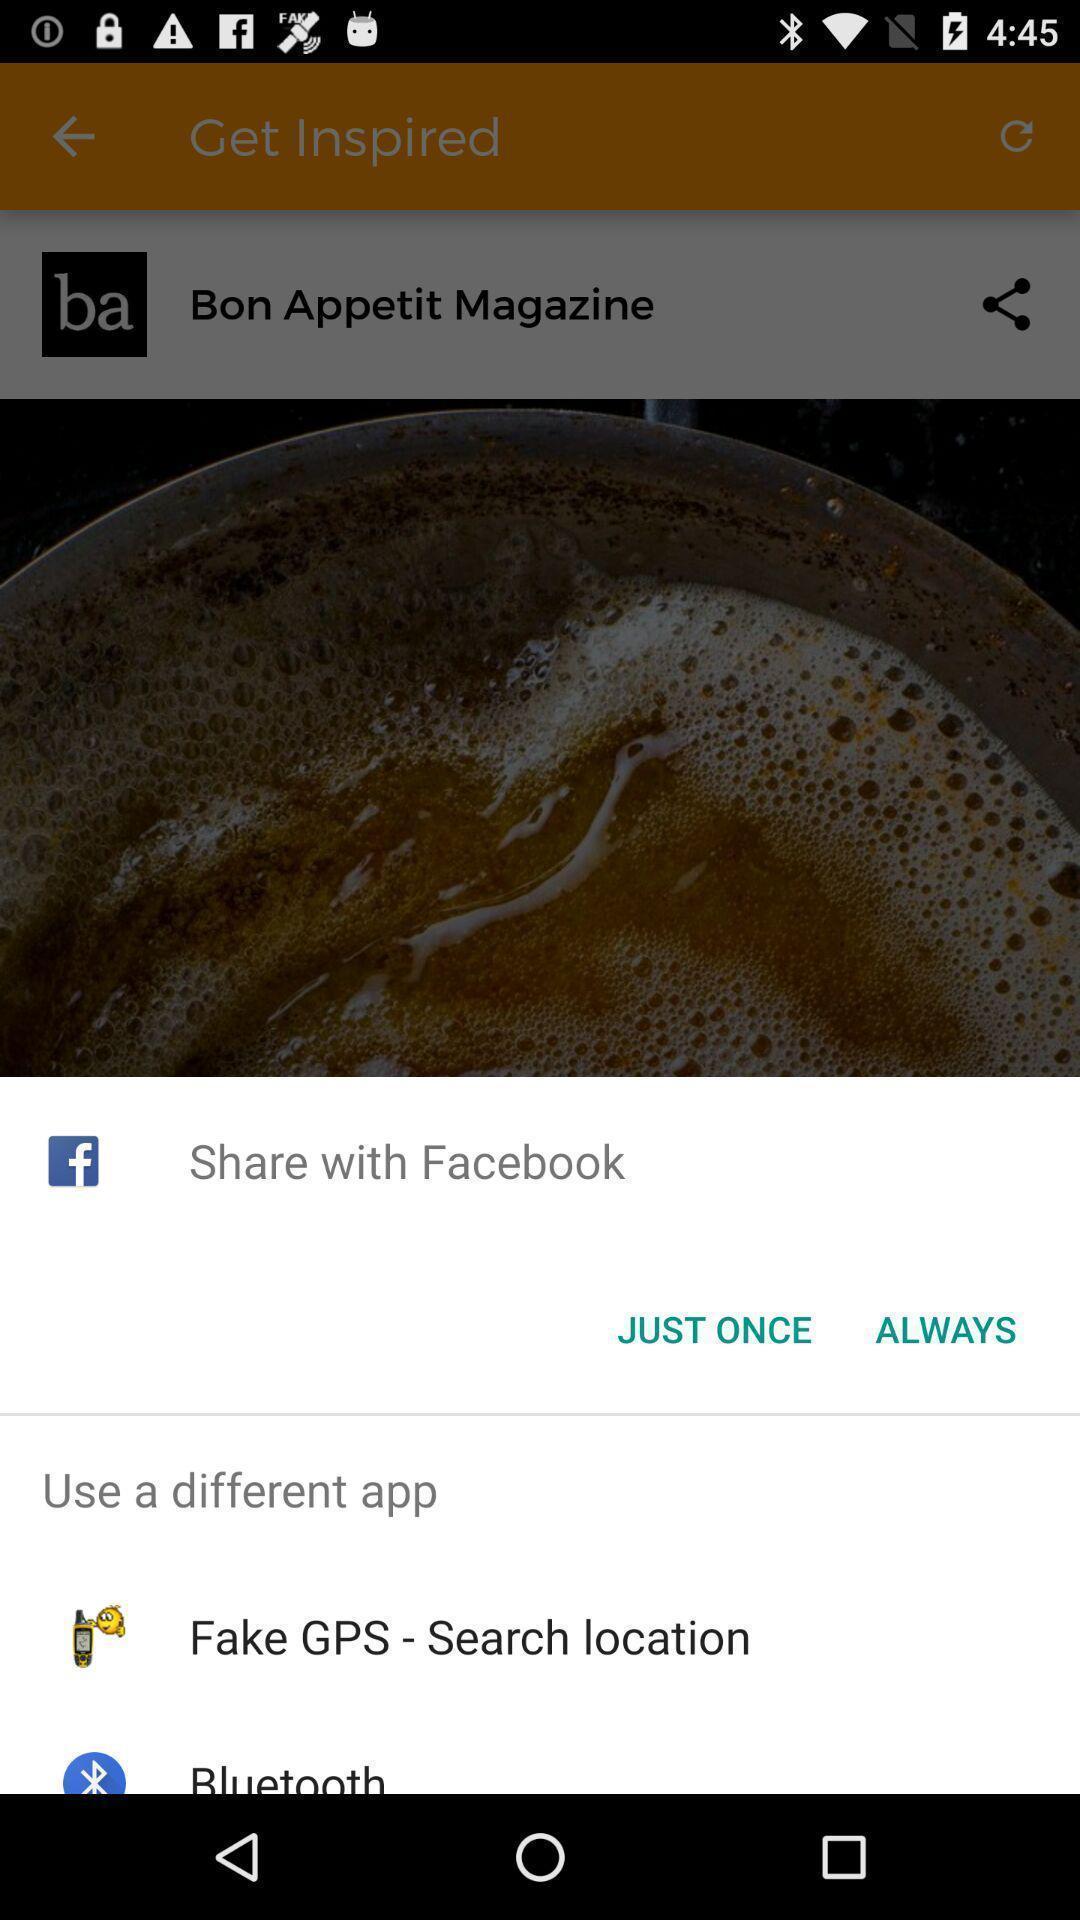Tell me about the visual elements in this screen capture. Pop-up widget showing different apps for sharing. 